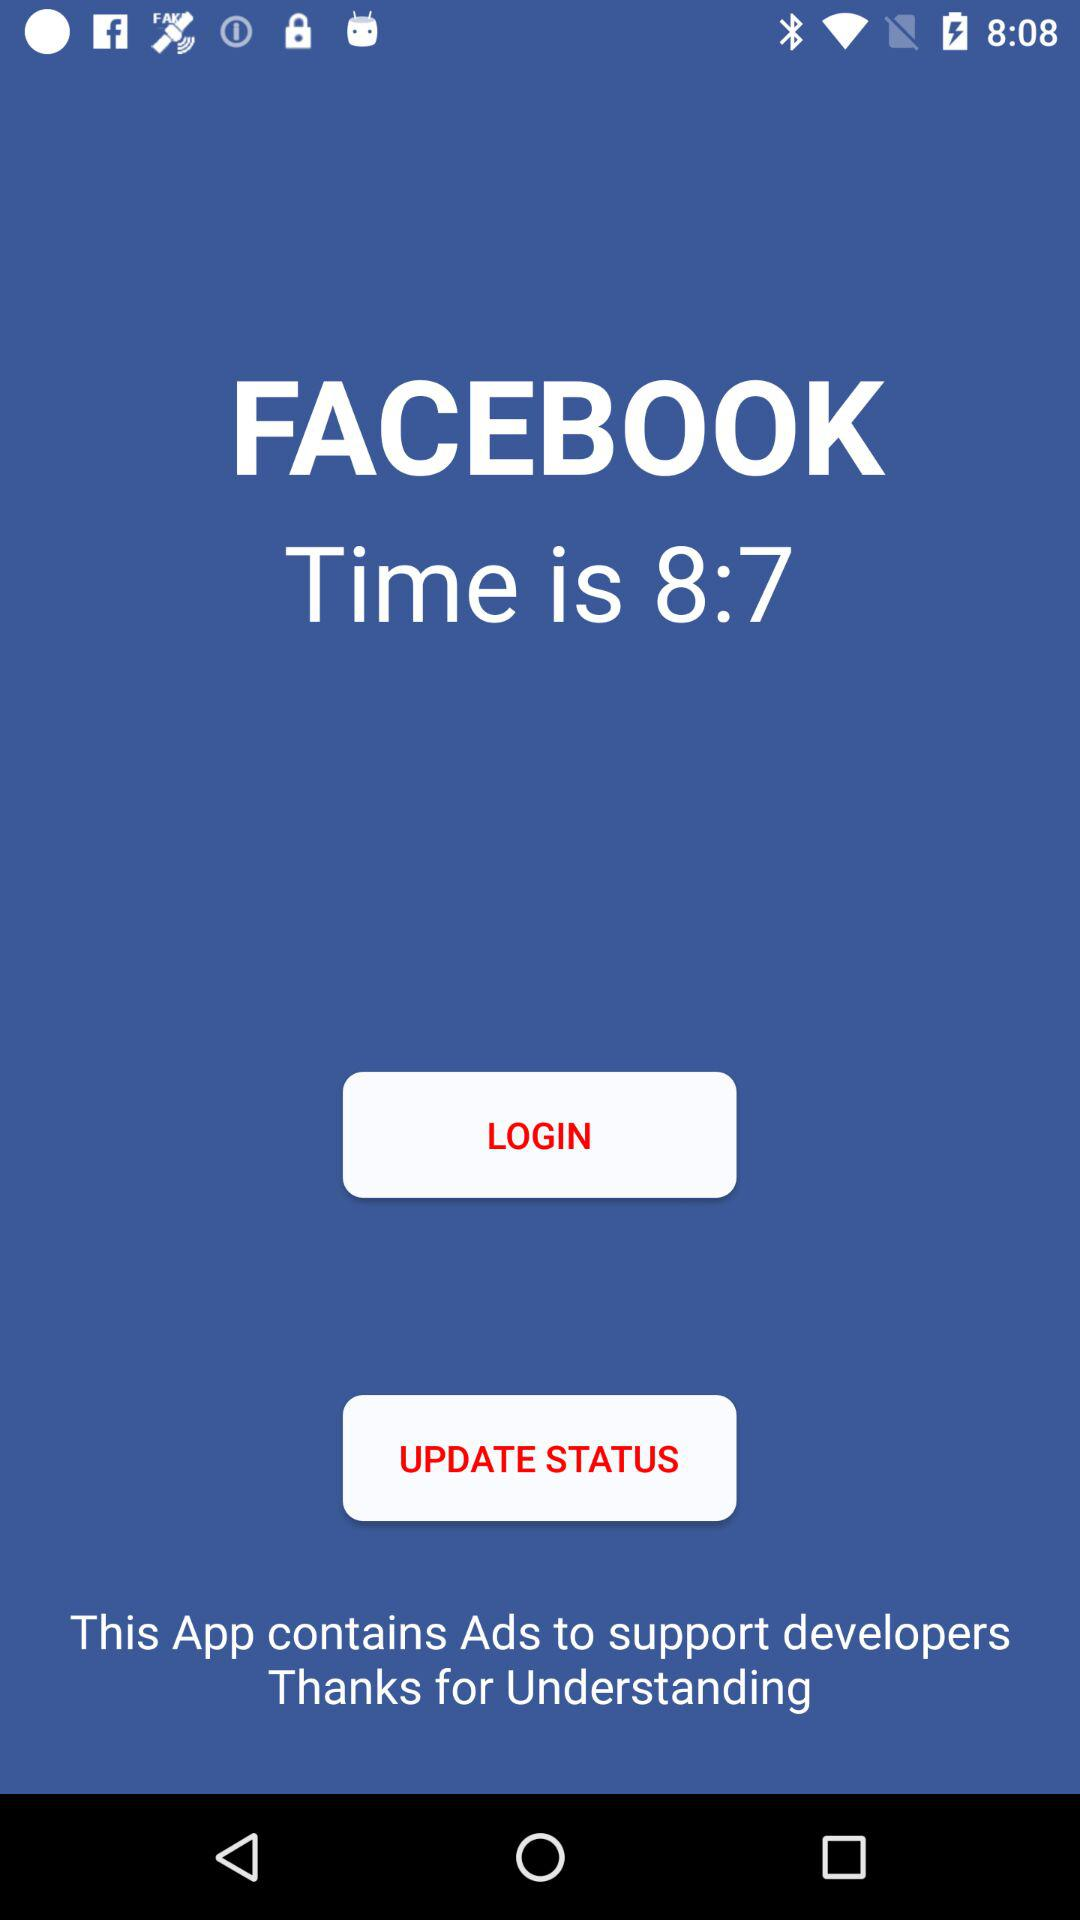What is the time? The time is 8:7. 